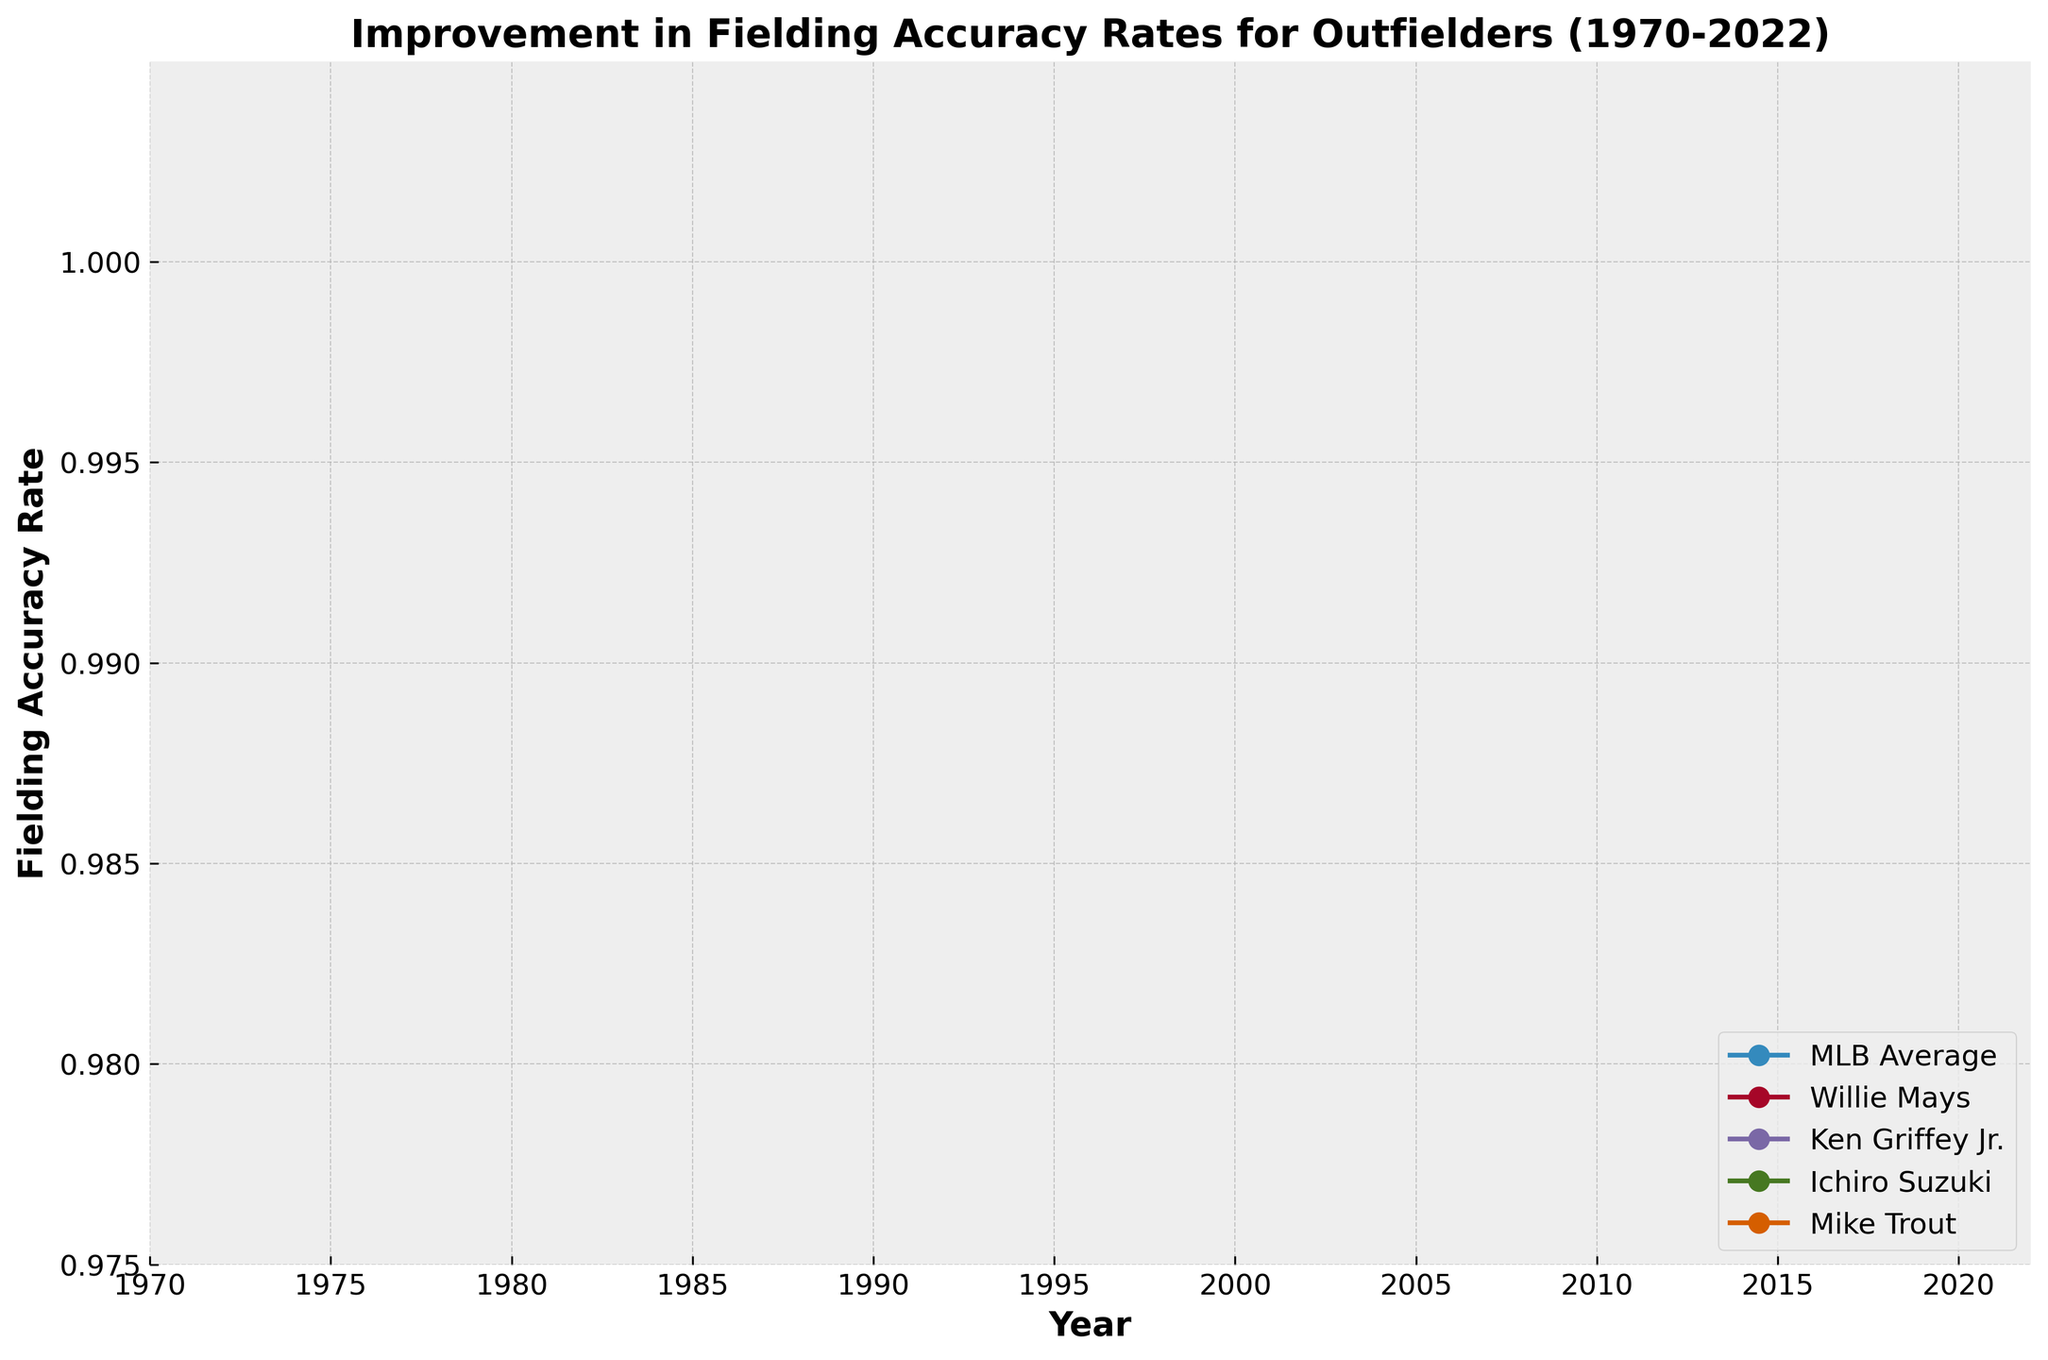Which player had the highest fielding accuracy rate in 2022? Locate the values on the chart at the year 2022 and compare the fielding accuracy rates of the players. Ichiro Suzuki has a fielding accuracy rate of 0.999, which is the highest among the players shown.
Answer: Ichiro Suzuki By how much did Mike Trout's fielding accuracy rate improve from 2010 to 2015? First, find Mike Trout's fielding accuracy rate in 2010 and 2015, which are 0.994 and 0.997 respectively. Then subtract the 2010 value from the 2015 value: 0.997 - 0.994 = 0.003.
Answer: 0.003 Who had a higher fielding accuracy rate in 2000, Ken Griffey Jr. or Ichiro Suzuki? Compare the fielding accuracy rates of Ken Griffey Jr. and Ichiro Suzuki in the year 2000. Ken Griffey Jr.'s value is 0.994, and Ichiro Suzuki's value is 0.997.
Answer: Ichiro Suzuki How does the MLB average fielding accuracy rate compare with Willie Mays in the 1970s? Look at the MLB Average and Willie Mays's accuracy rates from 1970 to 1975. Willie Mays has rates of 0.987 and 0.985, while the MLB Average shows 0.978 and 0.980. Thus, Willie Mays had higher accuracy rates.
Answer: Willie Mays is higher Calculate the average fielding accuracy rate for Ichiro Suzuki across the years provided. Identify Ichiro Suzuki's values which are 0.997, 0.998, 0.998, 0.996, and 0.999. Sum these values and divide by the number of years: (0.997 + 0.998 + 0.998 + 0.996 + 0.999)/5 = 4.988/5 = 0.9976.
Answer: 0.9976 What trend can be observed in the MLB average fielding accuracy rate from 1970 to 2022? Observe and describe the overall movement of the MLB average line from 1970 to 2022. The line shows a general upward trend, indicating continuous improvement over the years.
Answer: Upward trend 